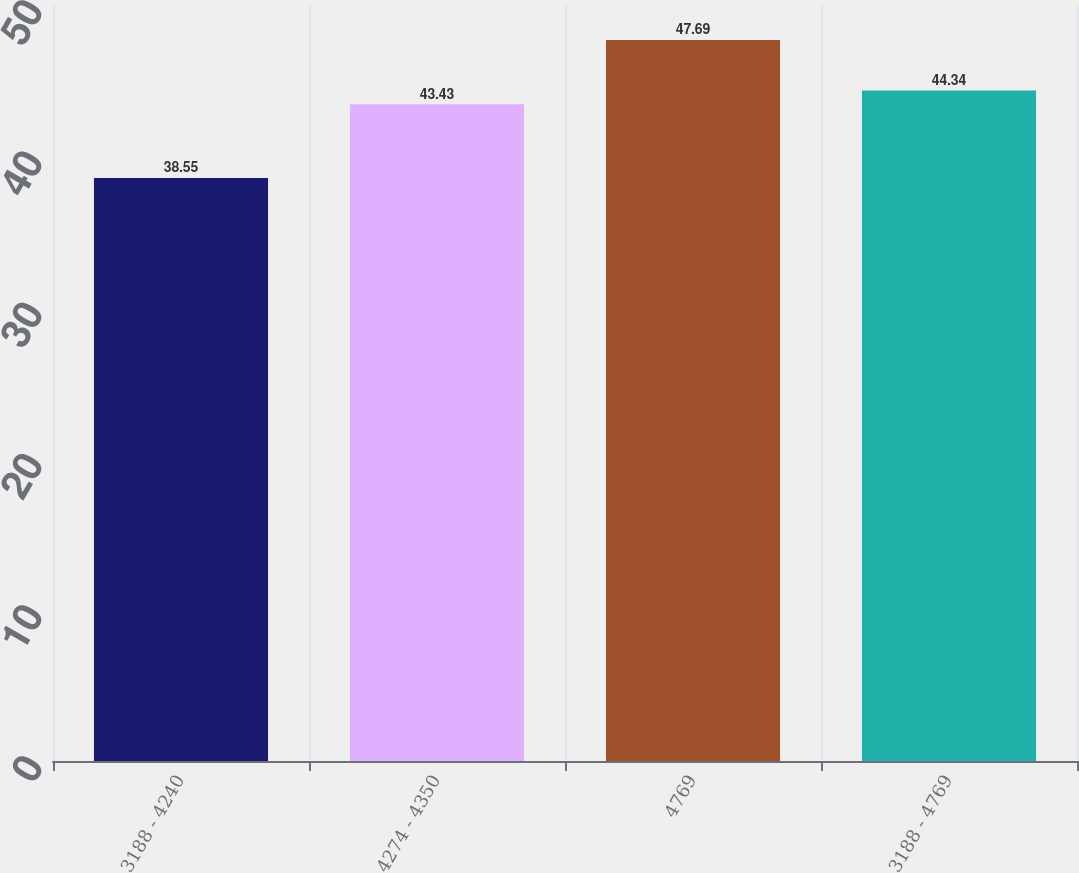<chart> <loc_0><loc_0><loc_500><loc_500><bar_chart><fcel>3188 - 4240<fcel>4274 - 4350<fcel>4769<fcel>3188 - 4769<nl><fcel>38.55<fcel>43.43<fcel>47.69<fcel>44.34<nl></chart> 